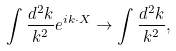Convert formula to latex. <formula><loc_0><loc_0><loc_500><loc_500>\int \frac { d ^ { 2 } k } { k ^ { 2 } } e ^ { i k \cdot X } \rightarrow \int \frac { d ^ { 2 } k } { k ^ { 2 } } ,</formula> 